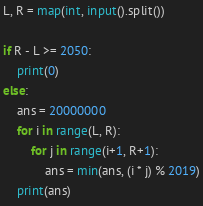Convert code to text. <code><loc_0><loc_0><loc_500><loc_500><_Python_>L, R = map(int, input().split())

if R - L >= 2050:
    print(0)
else:
    ans = 20000000
    for i in range(L, R):
        for j in range(i+1, R+1):
            ans = min(ans, (i * j) % 2019)
    print(ans)
</code> 